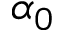<formula> <loc_0><loc_0><loc_500><loc_500>\alpha _ { 0 }</formula> 